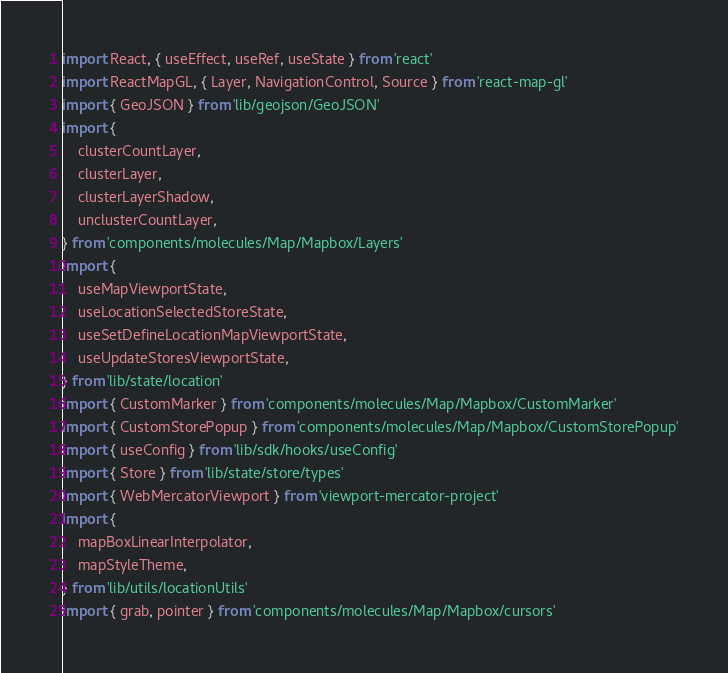Convert code to text. <code><loc_0><loc_0><loc_500><loc_500><_TypeScript_>import React, { useEffect, useRef, useState } from 'react'
import ReactMapGL, { Layer, NavigationControl, Source } from 'react-map-gl'
import { GeoJSON } from 'lib/geojson/GeoJSON'
import {
    clusterCountLayer,
    clusterLayer,
    clusterLayerShadow,
    unclusterCountLayer,
} from 'components/molecules/Map/Mapbox/Layers'
import {
    useMapViewportState,
    useLocationSelectedStoreState,
    useSetDefineLocationMapViewportState,
    useUpdateStoresViewportState,
} from 'lib/state/location'
import { CustomMarker } from 'components/molecules/Map/Mapbox/CustomMarker'
import { CustomStorePopup } from 'components/molecules/Map/Mapbox/CustomStorePopup'
import { useConfig } from 'lib/sdk/hooks/useConfig'
import { Store } from 'lib/state/store/types'
import { WebMercatorViewport } from 'viewport-mercator-project'
import {
    mapBoxLinearInterpolator,
    mapStyleTheme,
} from 'lib/utils/locationUtils'
import { grab, pointer } from 'components/molecules/Map/Mapbox/cursors'</code> 